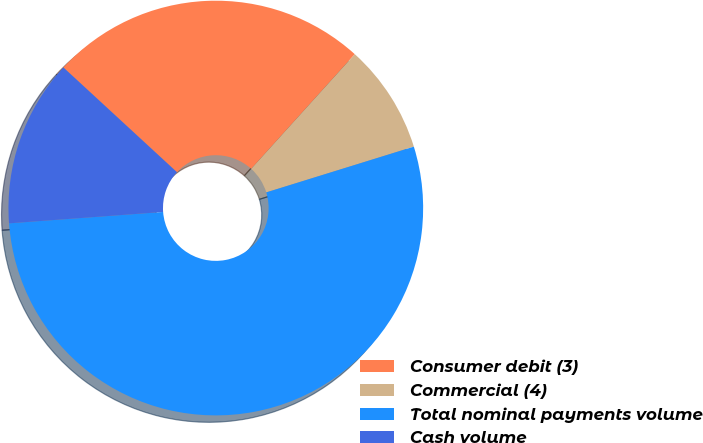Convert chart to OTSL. <chart><loc_0><loc_0><loc_500><loc_500><pie_chart><fcel>Consumer debit (3)<fcel>Commercial (4)<fcel>Total nominal payments volume<fcel>Cash volume<nl><fcel>24.84%<fcel>8.52%<fcel>53.61%<fcel>13.03%<nl></chart> 